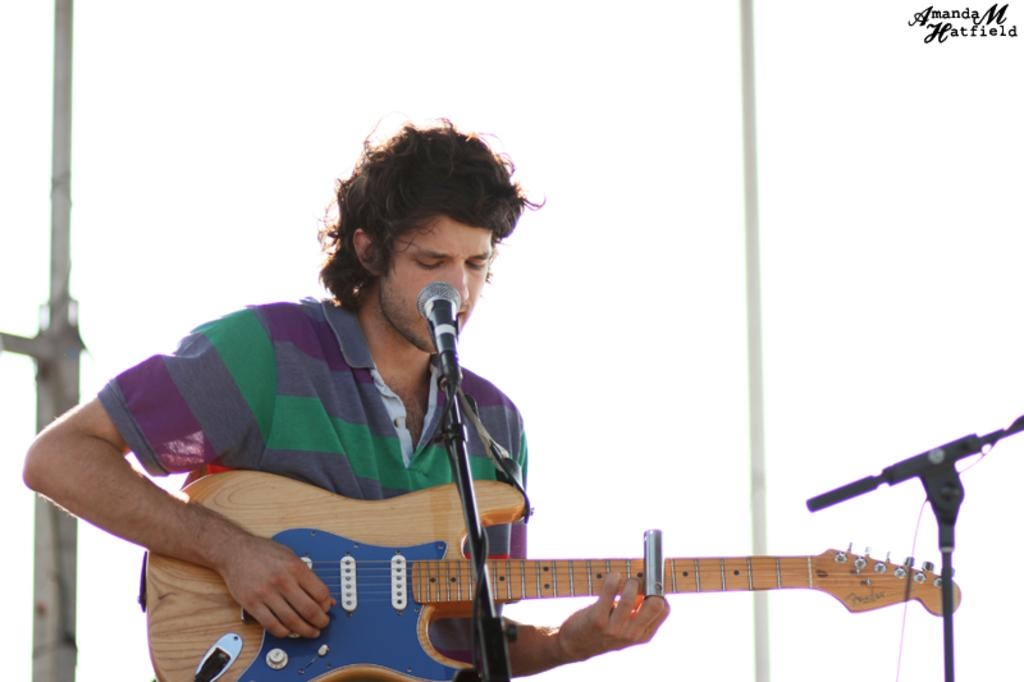What is the man in the image holding? The man is holding a guitar. What is in front of the man? There is a microphone in front of the man. What is the man wearing on his upper body? The man is wearing a t-shirt. Is the man in the image standing in quicksand? There is no indication of quicksand in the image; the man is standing on a solid surface. 